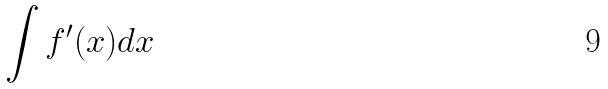<formula> <loc_0><loc_0><loc_500><loc_500>\int f ^ { \prime } ( x ) d x</formula> 